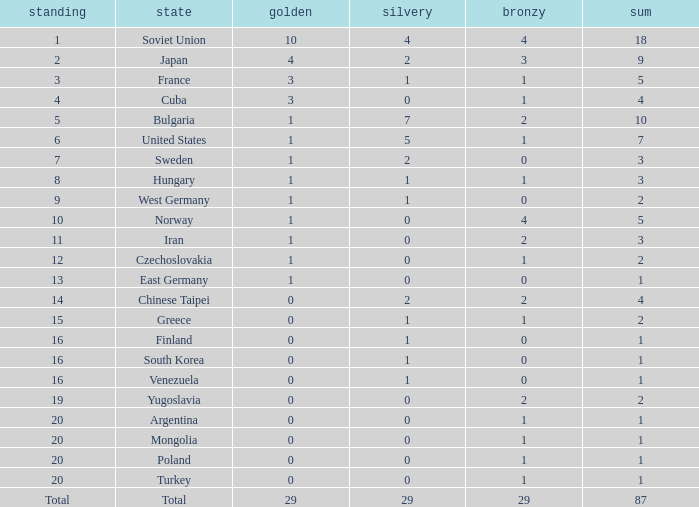What is the average number of bronze medals for total of all nations? 29.0. 